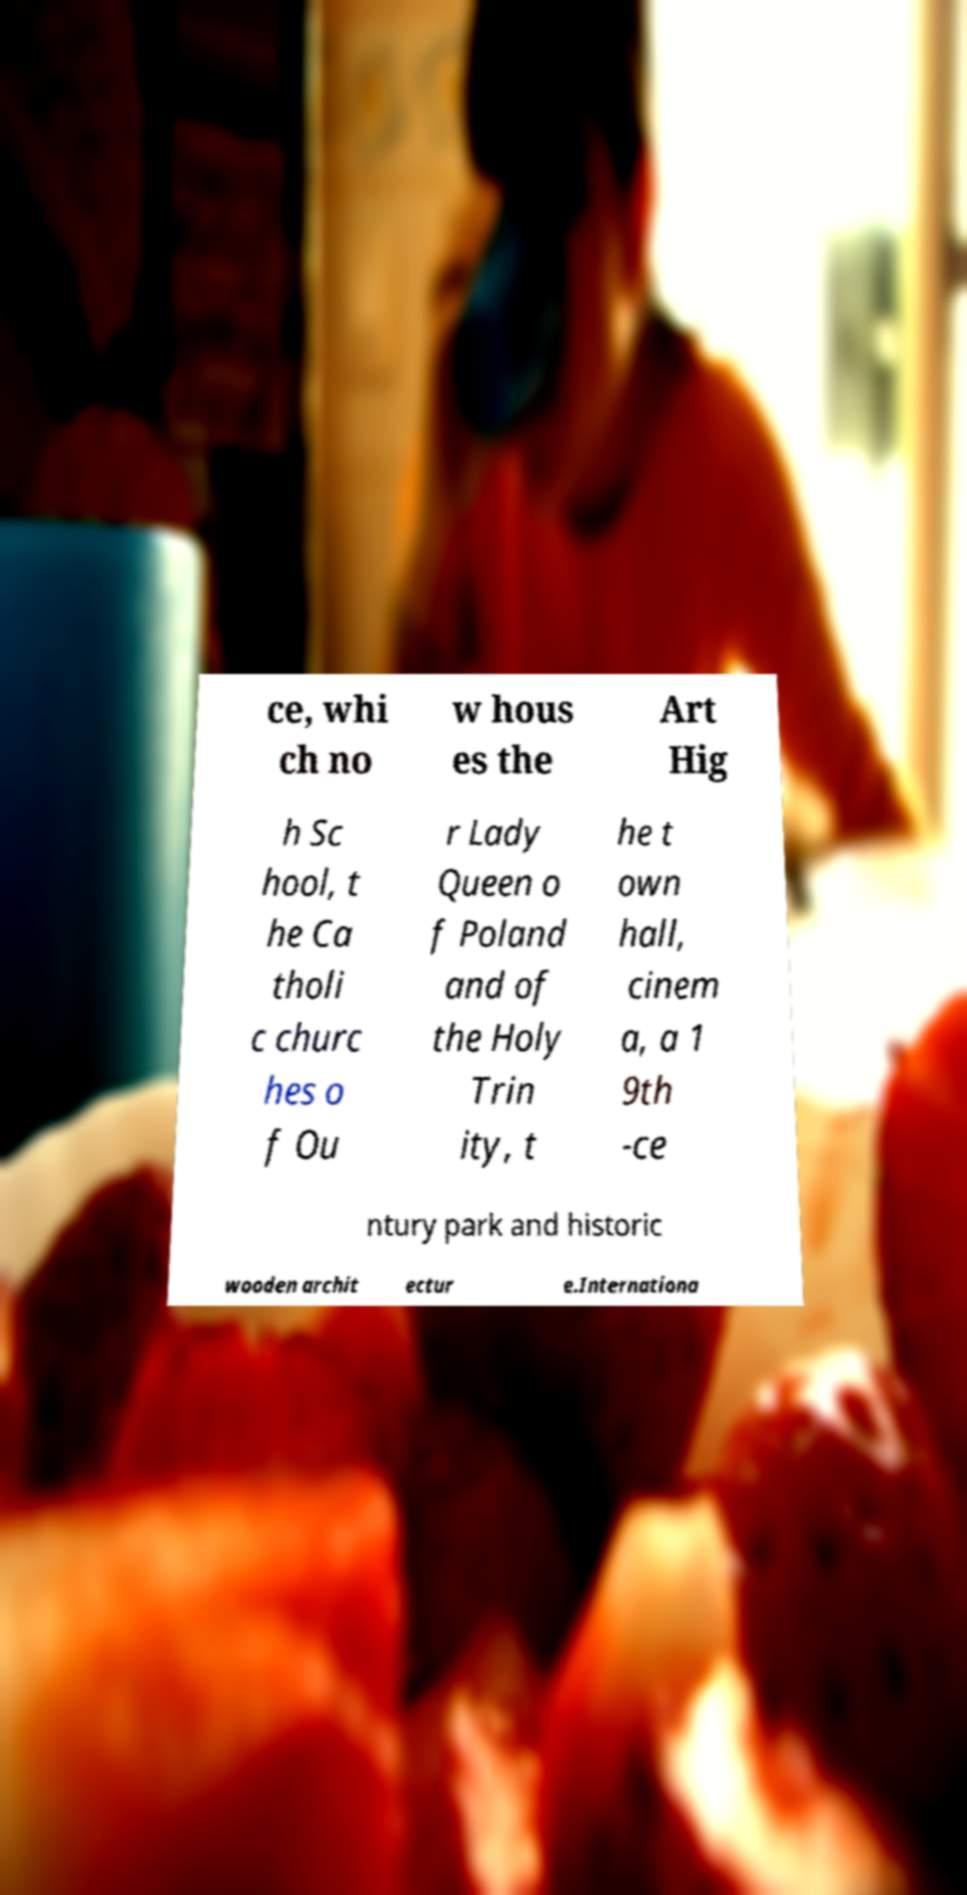I need the written content from this picture converted into text. Can you do that? ce, whi ch no w hous es the Art Hig h Sc hool, t he Ca tholi c churc hes o f Ou r Lady Queen o f Poland and of the Holy Trin ity, t he t own hall, cinem a, a 1 9th -ce ntury park and historic wooden archit ectur e.Internationa 